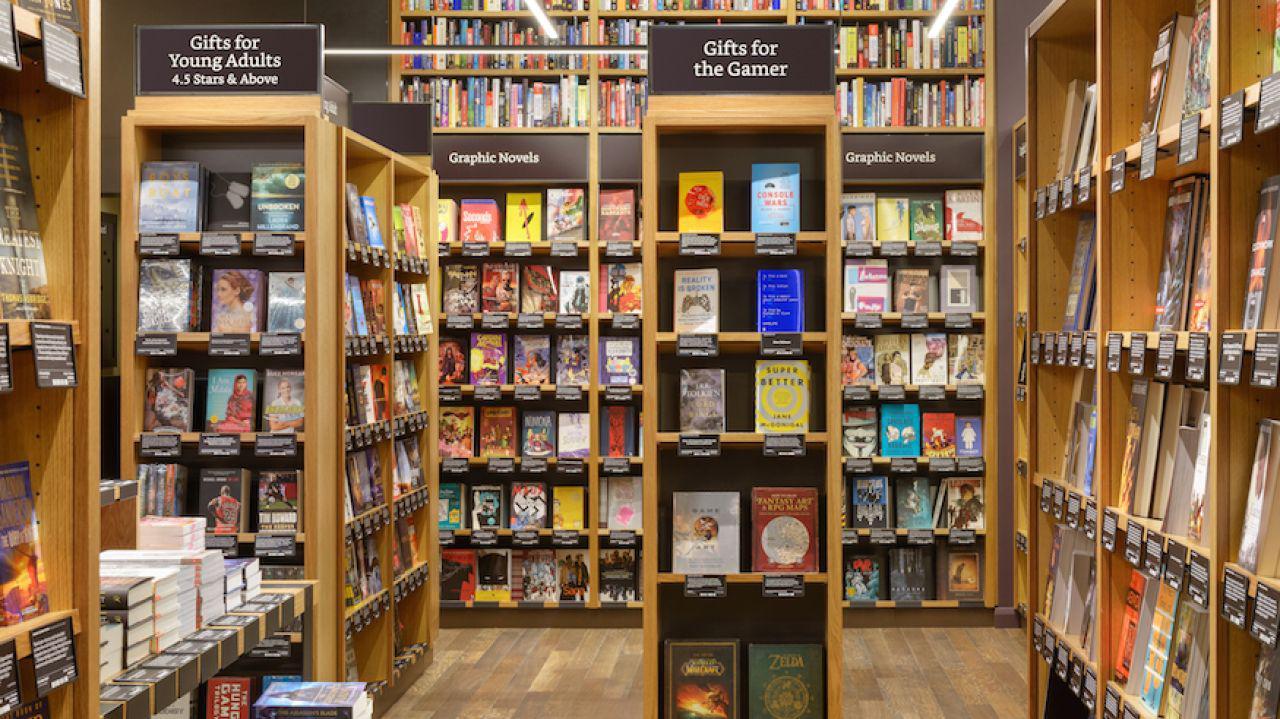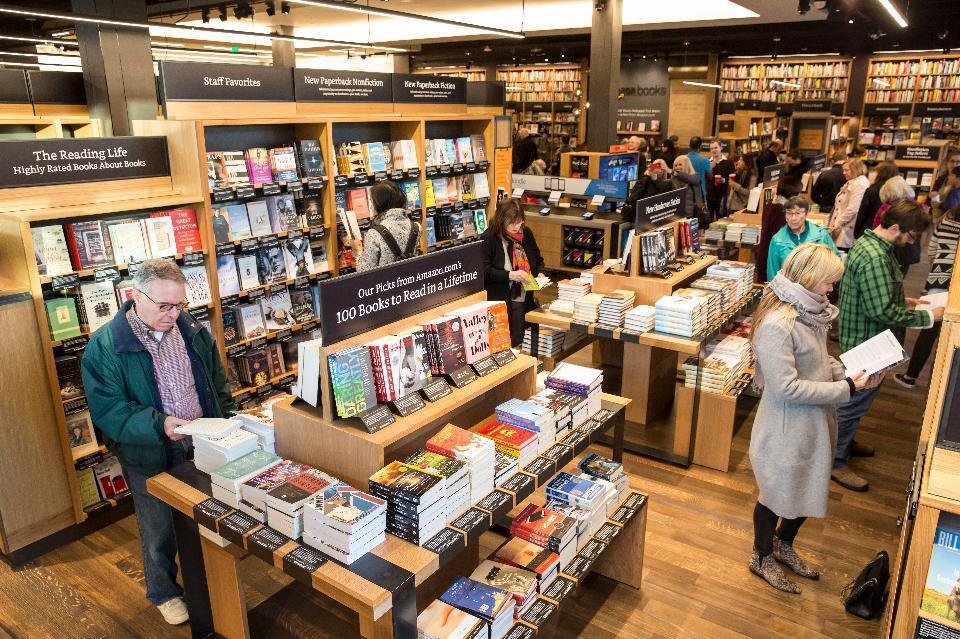The first image is the image on the left, the second image is the image on the right. Evaluate the accuracy of this statement regarding the images: "There are no more than 4 people in the image on the right.". Is it true? Answer yes or no. No. 